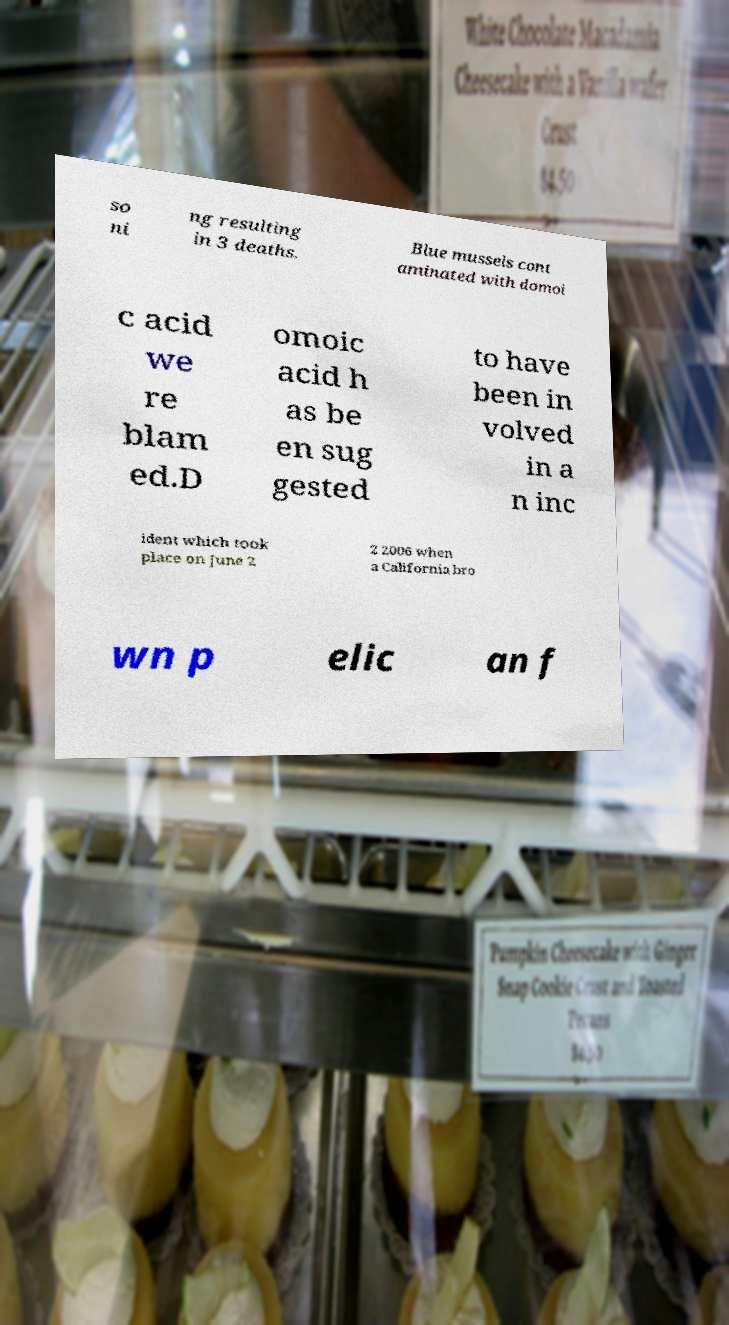For documentation purposes, I need the text within this image transcribed. Could you provide that? so ni ng resulting in 3 deaths. Blue mussels cont aminated with domoi c acid we re blam ed.D omoic acid h as be en sug gested to have been in volved in a n inc ident which took place on June 2 2 2006 when a California bro wn p elic an f 